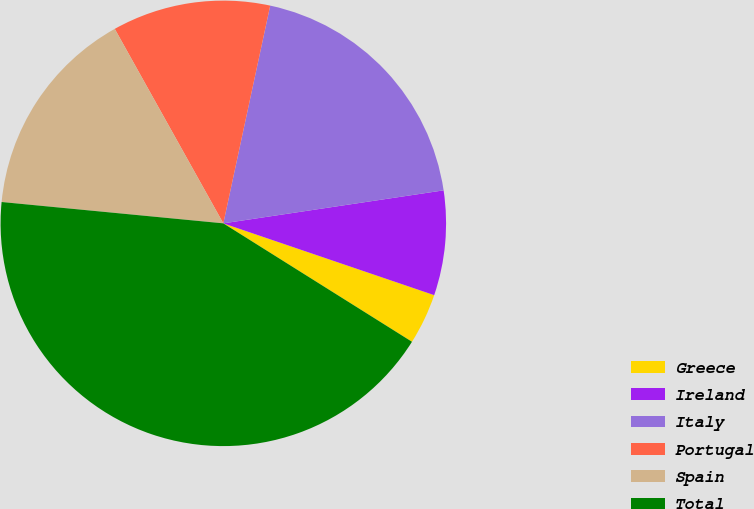Convert chart to OTSL. <chart><loc_0><loc_0><loc_500><loc_500><pie_chart><fcel>Greece<fcel>Ireland<fcel>Italy<fcel>Portugal<fcel>Spain<fcel>Total<nl><fcel>3.7%<fcel>7.59%<fcel>19.26%<fcel>11.48%<fcel>15.37%<fcel>42.61%<nl></chart> 